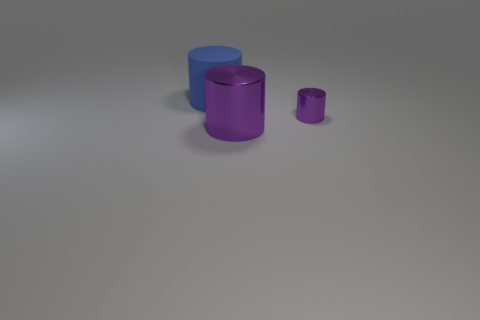Is there any other thing that is the same size as the rubber cylinder?
Keep it short and to the point. Yes. Are there any big shiny objects that have the same color as the large metallic cylinder?
Offer a terse response. No. Is there a large rubber thing?
Provide a short and direct response. Yes. Is the tiny purple metallic object the same shape as the big blue matte thing?
Your answer should be very brief. Yes. What number of small things are green matte cylinders or blue things?
Give a very brief answer. 0. What color is the large matte object?
Give a very brief answer. Blue. What shape is the large object that is in front of the metal cylinder behind the large purple metallic object?
Ensure brevity in your answer.  Cylinder. Is there a big purple thing made of the same material as the small purple cylinder?
Provide a succinct answer. Yes. How many green things are cylinders or tiny shiny cylinders?
Make the answer very short. 0. There is a big cylinder in front of the rubber object; what is it made of?
Make the answer very short. Metal. 